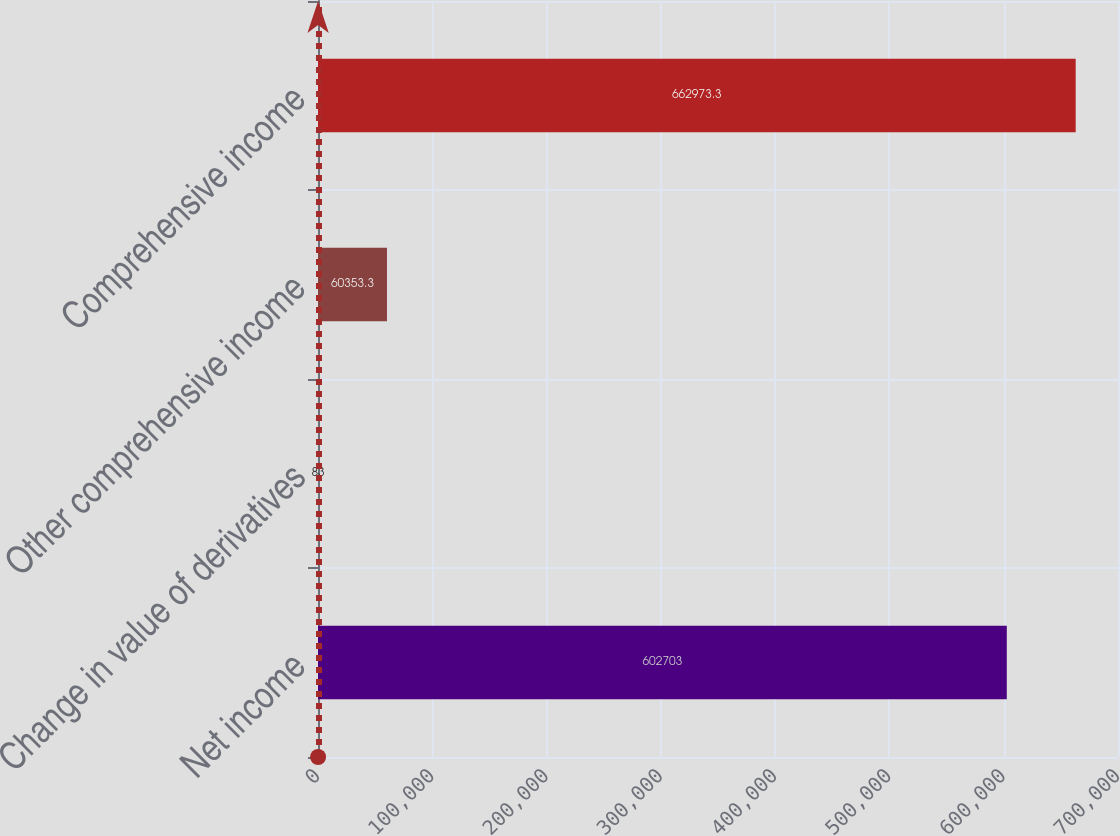Convert chart. <chart><loc_0><loc_0><loc_500><loc_500><bar_chart><fcel>Net income<fcel>Change in value of derivatives<fcel>Other comprehensive income<fcel>Comprehensive income<nl><fcel>602703<fcel>83<fcel>60353.3<fcel>662973<nl></chart> 